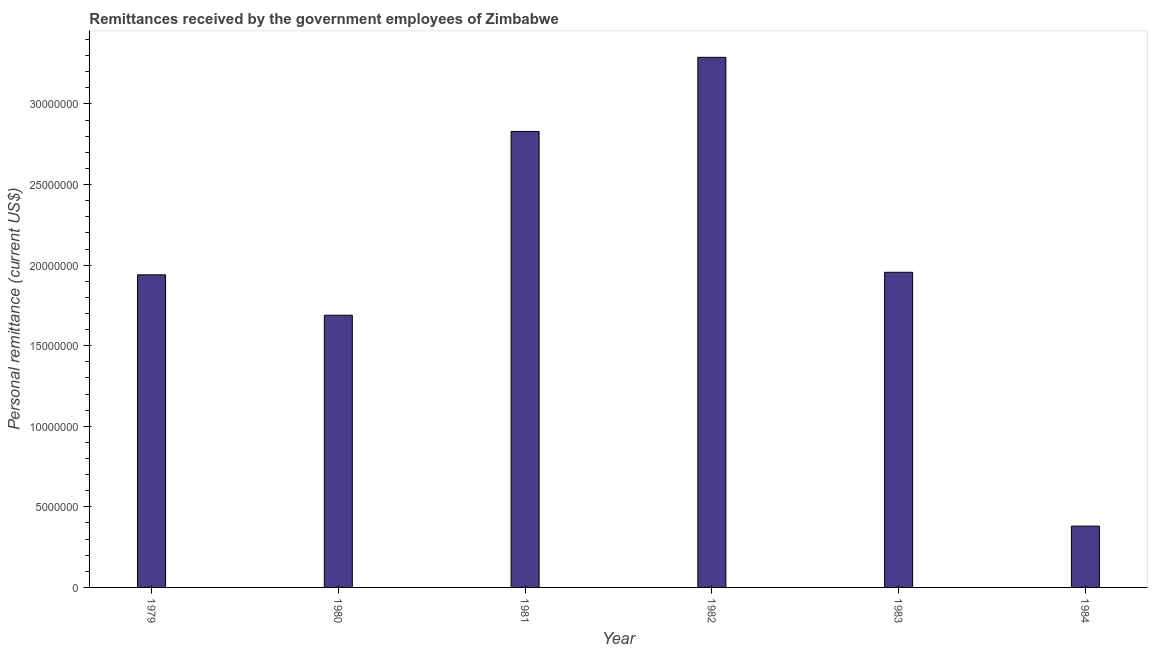Does the graph contain grids?
Offer a very short reply. No. What is the title of the graph?
Make the answer very short. Remittances received by the government employees of Zimbabwe. What is the label or title of the Y-axis?
Ensure brevity in your answer.  Personal remittance (current US$). What is the personal remittances in 1983?
Provide a short and direct response. 1.96e+07. Across all years, what is the maximum personal remittances?
Provide a succinct answer. 3.29e+07. Across all years, what is the minimum personal remittances?
Your answer should be compact. 3.81e+06. In which year was the personal remittances maximum?
Keep it short and to the point. 1982. What is the sum of the personal remittances?
Offer a terse response. 1.21e+08. What is the difference between the personal remittances in 1979 and 1984?
Your response must be concise. 1.56e+07. What is the average personal remittances per year?
Provide a short and direct response. 2.01e+07. What is the median personal remittances?
Your answer should be very brief. 1.95e+07. In how many years, is the personal remittances greater than 28000000 US$?
Offer a terse response. 2. What is the ratio of the personal remittances in 1980 to that in 1984?
Provide a short and direct response. 4.44. Is the difference between the personal remittances in 1980 and 1981 greater than the difference between any two years?
Provide a succinct answer. No. What is the difference between the highest and the second highest personal remittances?
Your response must be concise. 4.60e+06. What is the difference between the highest and the lowest personal remittances?
Ensure brevity in your answer.  2.91e+07. Are all the bars in the graph horizontal?
Make the answer very short. No. What is the difference between two consecutive major ticks on the Y-axis?
Offer a very short reply. 5.00e+06. What is the Personal remittance (current US$) in 1979?
Keep it short and to the point. 1.94e+07. What is the Personal remittance (current US$) in 1980?
Your response must be concise. 1.69e+07. What is the Personal remittance (current US$) of 1981?
Make the answer very short. 2.83e+07. What is the Personal remittance (current US$) in 1982?
Make the answer very short. 3.29e+07. What is the Personal remittance (current US$) in 1983?
Make the answer very short. 1.96e+07. What is the Personal remittance (current US$) in 1984?
Make the answer very short. 3.81e+06. What is the difference between the Personal remittance (current US$) in 1979 and 1980?
Offer a terse response. 2.51e+06. What is the difference between the Personal remittance (current US$) in 1979 and 1981?
Ensure brevity in your answer.  -8.90e+06. What is the difference between the Personal remittance (current US$) in 1979 and 1982?
Provide a succinct answer. -1.35e+07. What is the difference between the Personal remittance (current US$) in 1979 and 1983?
Give a very brief answer. -1.59e+05. What is the difference between the Personal remittance (current US$) in 1979 and 1984?
Provide a short and direct response. 1.56e+07. What is the difference between the Personal remittance (current US$) in 1980 and 1981?
Keep it short and to the point. -1.14e+07. What is the difference between the Personal remittance (current US$) in 1980 and 1982?
Provide a succinct answer. -1.60e+07. What is the difference between the Personal remittance (current US$) in 1980 and 1983?
Give a very brief answer. -2.66e+06. What is the difference between the Personal remittance (current US$) in 1980 and 1984?
Your answer should be very brief. 1.31e+07. What is the difference between the Personal remittance (current US$) in 1981 and 1982?
Offer a terse response. -4.60e+06. What is the difference between the Personal remittance (current US$) in 1981 and 1983?
Your response must be concise. 8.74e+06. What is the difference between the Personal remittance (current US$) in 1981 and 1984?
Offer a very short reply. 2.45e+07. What is the difference between the Personal remittance (current US$) in 1982 and 1983?
Make the answer very short. 1.33e+07. What is the difference between the Personal remittance (current US$) in 1982 and 1984?
Keep it short and to the point. 2.91e+07. What is the difference between the Personal remittance (current US$) in 1983 and 1984?
Your response must be concise. 1.57e+07. What is the ratio of the Personal remittance (current US$) in 1979 to that in 1980?
Offer a very short reply. 1.15. What is the ratio of the Personal remittance (current US$) in 1979 to that in 1981?
Your answer should be compact. 0.69. What is the ratio of the Personal remittance (current US$) in 1979 to that in 1982?
Your response must be concise. 0.59. What is the ratio of the Personal remittance (current US$) in 1979 to that in 1983?
Your answer should be compact. 0.99. What is the ratio of the Personal remittance (current US$) in 1979 to that in 1984?
Provide a succinct answer. 5.1. What is the ratio of the Personal remittance (current US$) in 1980 to that in 1981?
Your answer should be very brief. 0.6. What is the ratio of the Personal remittance (current US$) in 1980 to that in 1982?
Your answer should be very brief. 0.51. What is the ratio of the Personal remittance (current US$) in 1980 to that in 1983?
Your answer should be very brief. 0.86. What is the ratio of the Personal remittance (current US$) in 1980 to that in 1984?
Ensure brevity in your answer.  4.44. What is the ratio of the Personal remittance (current US$) in 1981 to that in 1982?
Offer a terse response. 0.86. What is the ratio of the Personal remittance (current US$) in 1981 to that in 1983?
Provide a succinct answer. 1.45. What is the ratio of the Personal remittance (current US$) in 1981 to that in 1984?
Provide a succinct answer. 7.43. What is the ratio of the Personal remittance (current US$) in 1982 to that in 1983?
Give a very brief answer. 1.68. What is the ratio of the Personal remittance (current US$) in 1982 to that in 1984?
Keep it short and to the point. 8.64. What is the ratio of the Personal remittance (current US$) in 1983 to that in 1984?
Your answer should be very brief. 5.14. 